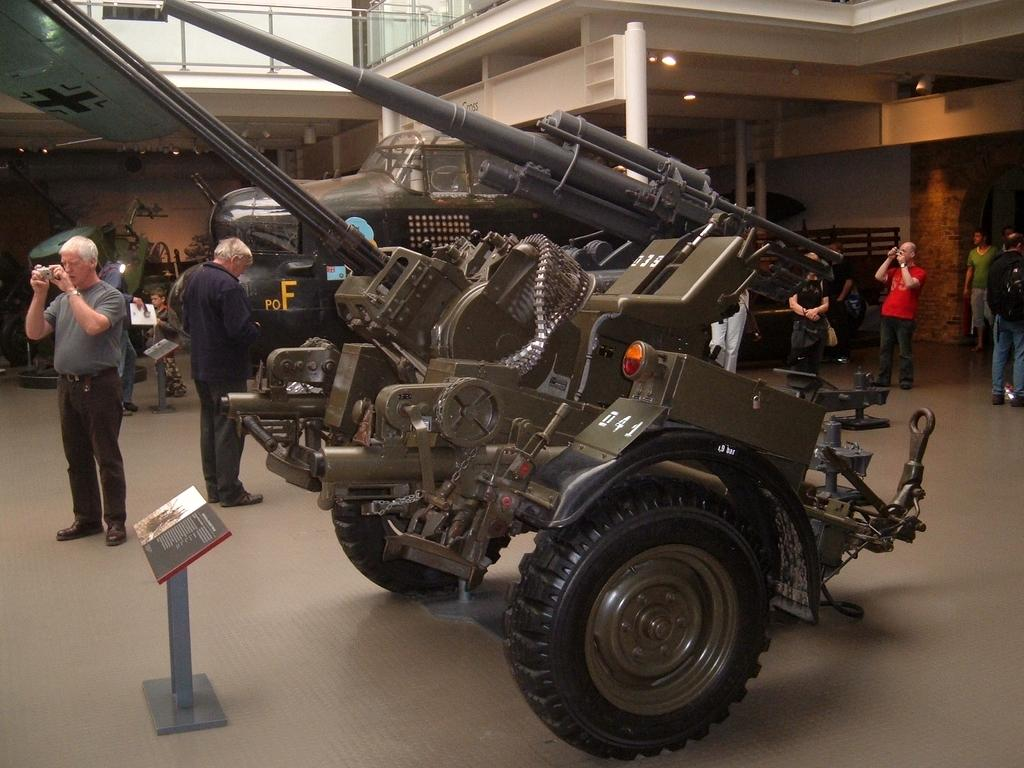What is the main subject in the image? There is a vehicle in the image. Are there any people present in the image? Yes, there are people in the image. What structures can be seen in the background of the image? There is a wall and a fence in the image. Can you describe the person on the left side of the image? A person is holding a camera on the left side of the image. What object is located in the front of the image? There is a book in the front of the image. What type of sink can be seen in the image? There is no sink present in the image. What season is depicted in the image? The provided facts do not mention any season, so it cannot be determined from the image. 